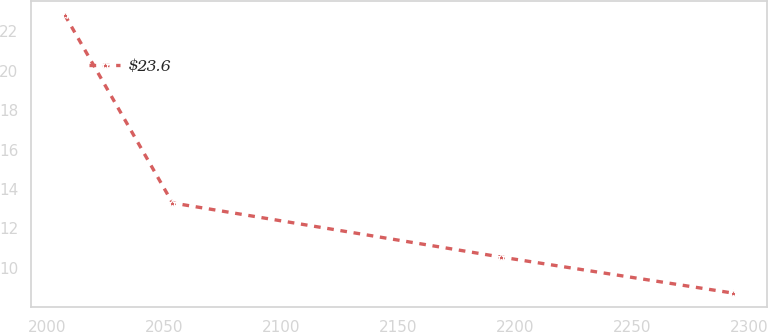<chart> <loc_0><loc_0><loc_500><loc_500><line_chart><ecel><fcel>$23.6<nl><fcel>2007.52<fcel>22.83<nl><fcel>2053.55<fcel>13.29<nl><fcel>2194.17<fcel>10.54<nl><fcel>2293.38<fcel>8.71<nl></chart> 